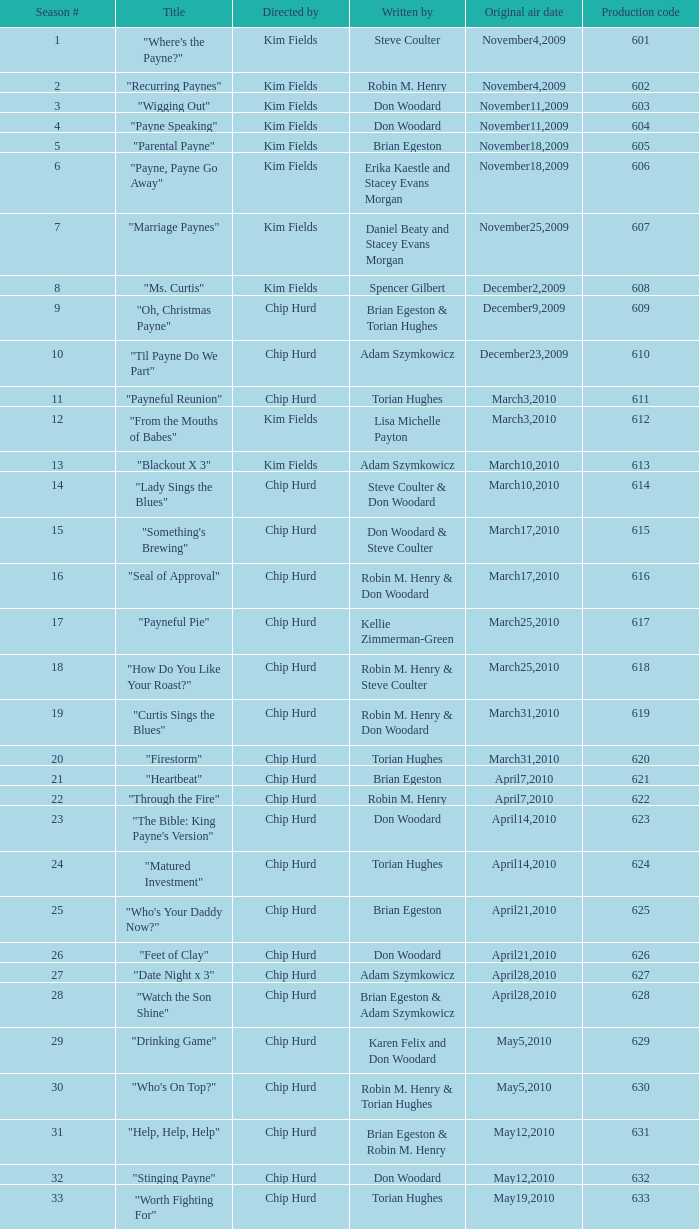Which episode has the production code 624 and what is its title? "Matured Investment". 